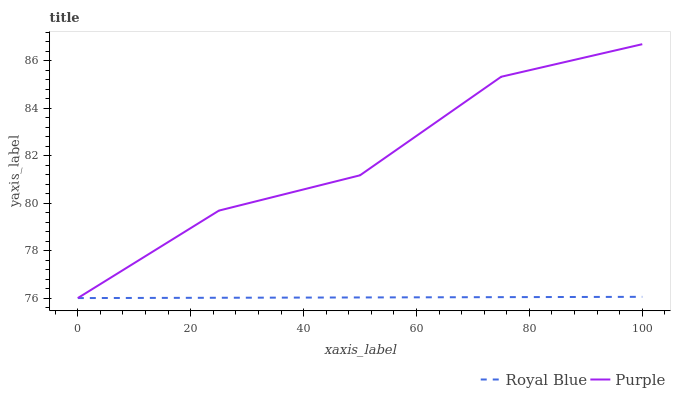Does Royal Blue have the maximum area under the curve?
Answer yes or no. No. Is Royal Blue the roughest?
Answer yes or no. No. Does Royal Blue have the highest value?
Answer yes or no. No. 